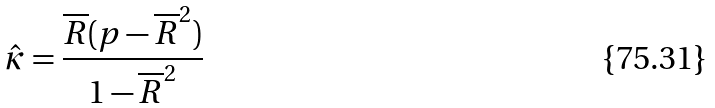<formula> <loc_0><loc_0><loc_500><loc_500>\hat { \kappa } = \frac { \overline { R } ( p - \overline { R } ^ { 2 } ) } { 1 - \overline { R } ^ { 2 } }</formula> 